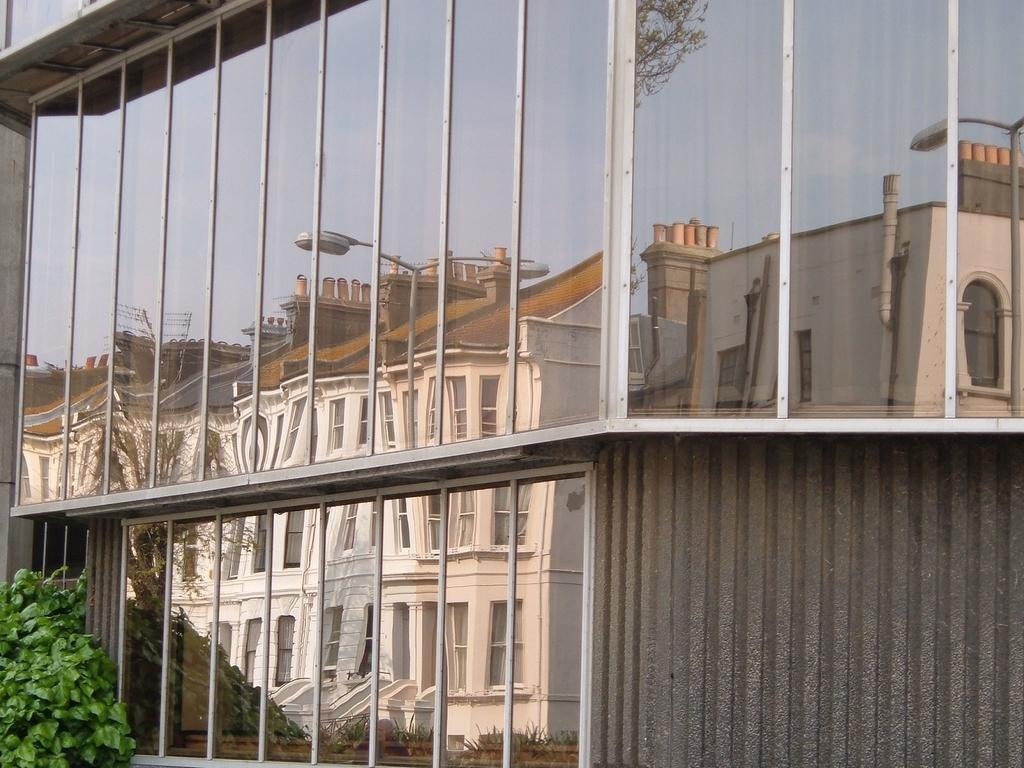What type of building is visible in the image? There is a building with glass windows in the image. What can be seen in the reflection of the glass windows? The reflection of the windows shows a white color building. Where is the plant located in the image? A plant is present in the left bottom of the image. What is the temper of the person celebrating their birthday in the image? There is no person celebrating their birthday in the image, nor is there any indication of a person's temper. 